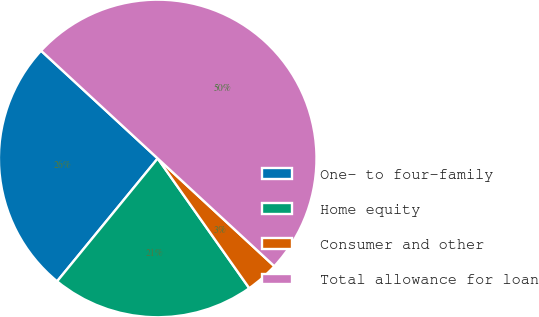Convert chart to OTSL. <chart><loc_0><loc_0><loc_500><loc_500><pie_chart><fcel>One- to four-family<fcel>Home equity<fcel>Consumer and other<fcel>Total allowance for loan<nl><fcel>25.95%<fcel>20.7%<fcel>3.35%<fcel>50.0%<nl></chart> 